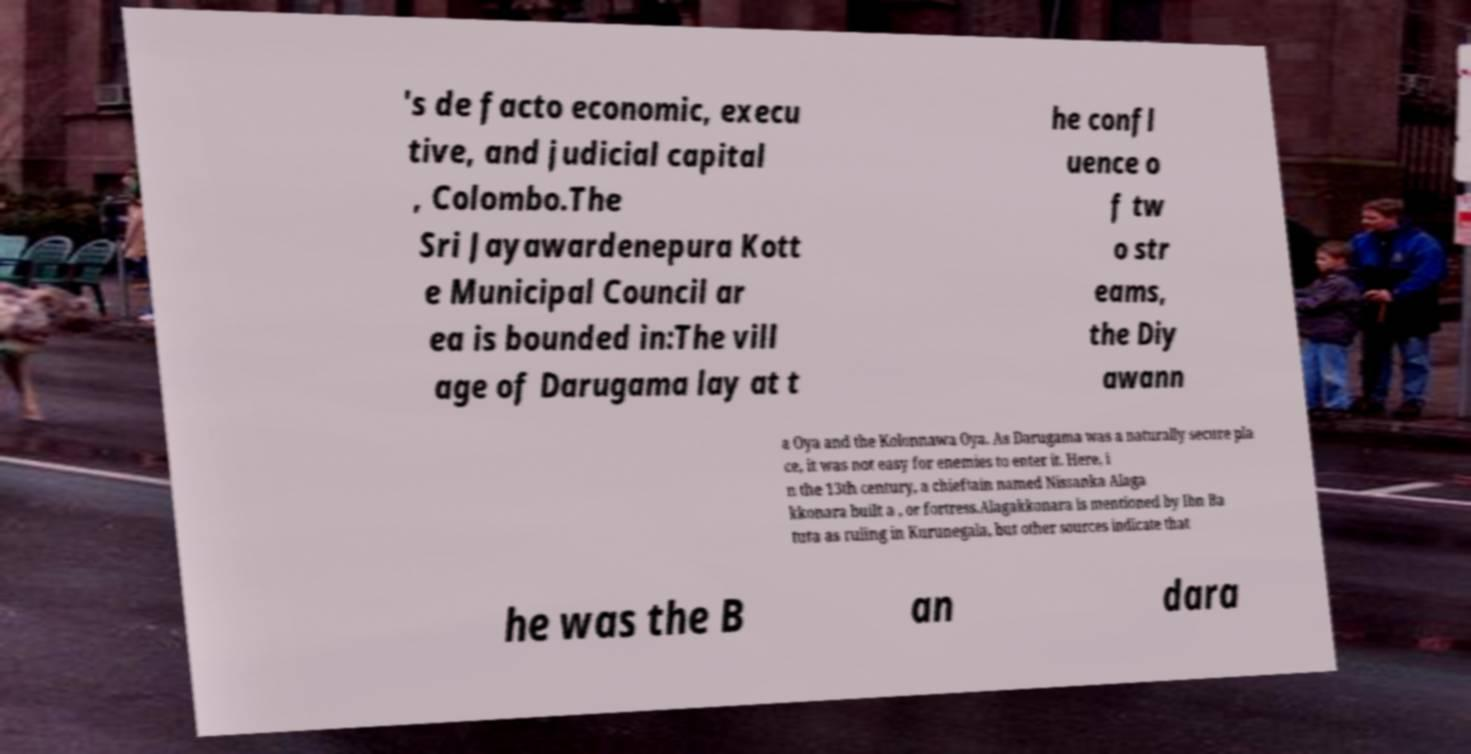Please read and relay the text visible in this image. What does it say? 's de facto economic, execu tive, and judicial capital , Colombo.The Sri Jayawardenepura Kott e Municipal Council ar ea is bounded in:The vill age of Darugama lay at t he confl uence o f tw o str eams, the Diy awann a Oya and the Kolonnawa Oya. As Darugama was a naturally secure pla ce, it was not easy for enemies to enter it. Here, i n the 13th century, a chieftain named Nissanka Alaga kkonara built a , or fortress.Alagakkonara is mentioned by Ibn Ba tuta as ruling in Kurunegala, but other sources indicate that he was the B an dara 